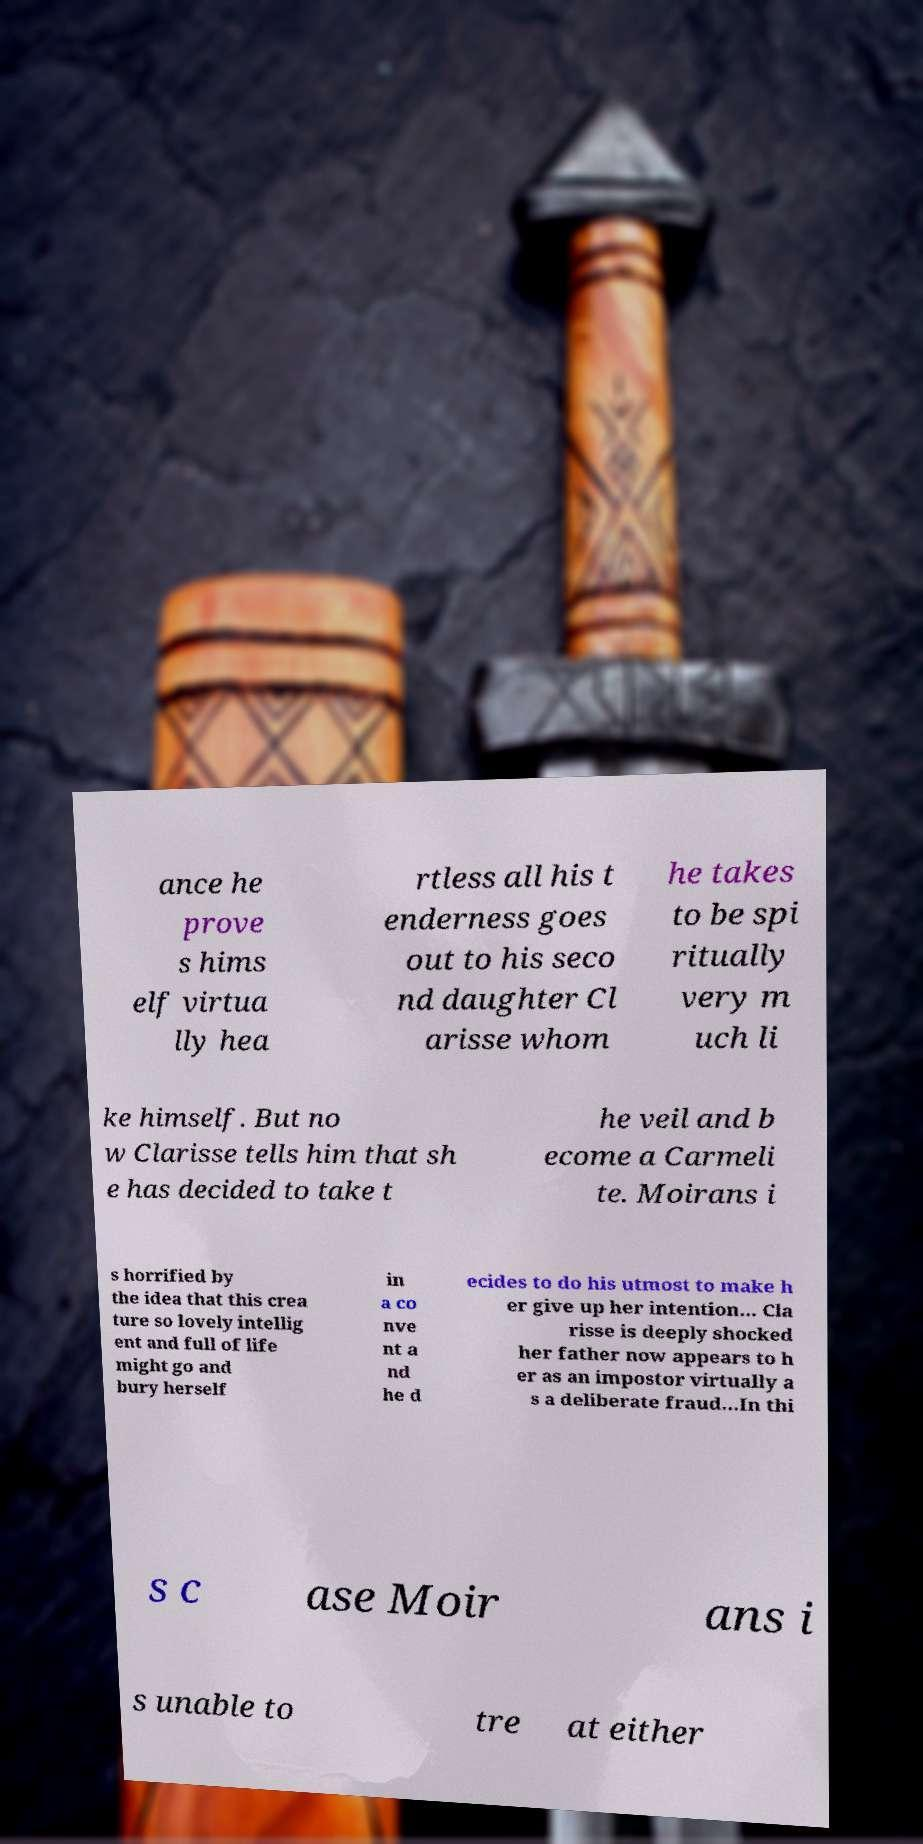Could you assist in decoding the text presented in this image and type it out clearly? ance he prove s hims elf virtua lly hea rtless all his t enderness goes out to his seco nd daughter Cl arisse whom he takes to be spi ritually very m uch li ke himself. But no w Clarisse tells him that sh e has decided to take t he veil and b ecome a Carmeli te. Moirans i s horrified by the idea that this crea ture so lovely intellig ent and full of life might go and bury herself in a co nve nt a nd he d ecides to do his utmost to make h er give up her intention... Cla risse is deeply shocked her father now appears to h er as an impostor virtually a s a deliberate fraud...In thi s c ase Moir ans i s unable to tre at either 